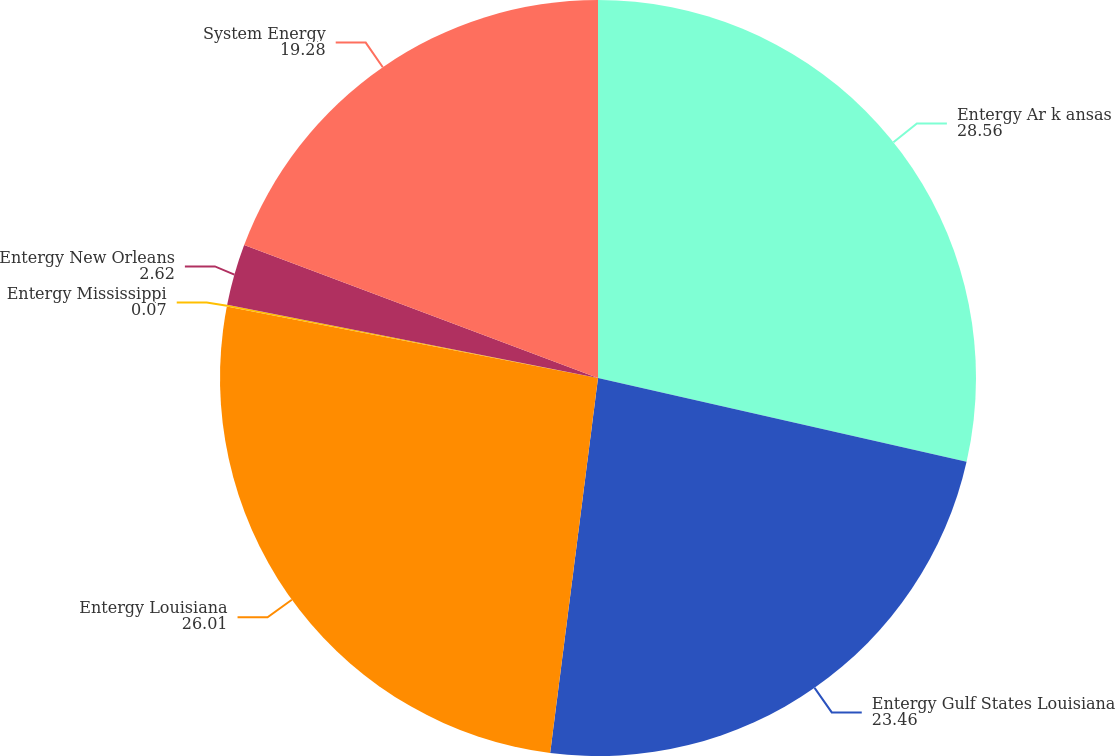Convert chart. <chart><loc_0><loc_0><loc_500><loc_500><pie_chart><fcel>Entergy Ar k ansas<fcel>Entergy Gulf States Louisiana<fcel>Entergy Louisiana<fcel>Entergy Mississippi<fcel>Entergy New Orleans<fcel>System Energy<nl><fcel>28.56%<fcel>23.46%<fcel>26.01%<fcel>0.07%<fcel>2.62%<fcel>19.28%<nl></chart> 